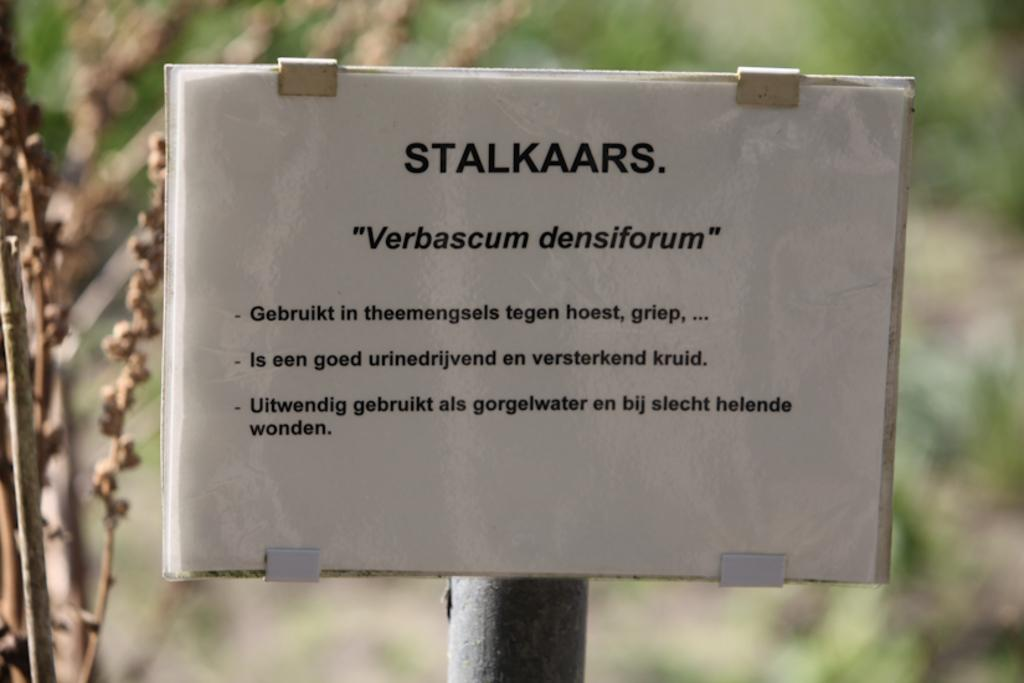What is on the paper that is visible in the image? There is a paper with text in the image. How is the paper positioned in the image? The paper is attached to a pole. What can be observed about the background of the image? The background of the image is slightly blurred. What color is the background of the image? The background color is green. What song is being sung in the background of the image? There is no indication of a song being sung in the image; it only features a paper with text attached to a pole against a green background. 